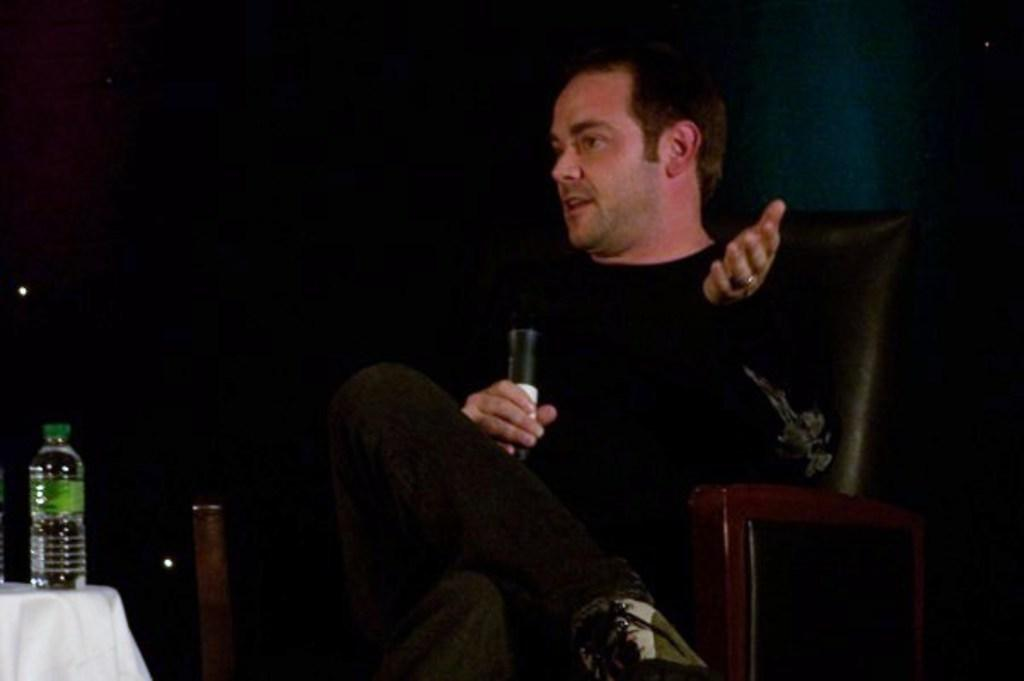Who is in the image? There is a man in the image. What is the man wearing? The man is wearing a black t-shirt. What is the man doing in the image? The man is sitting on a chair and holding a mic. What is in front of the man? There is a table in front of the man. What is on the table? There is a cloth and a bottle on the table. What type of spy equipment can be seen on the table in the image? There is no spy equipment present in the image; it features a man sitting on a chair, holding a mic, and a table with a cloth and a bottle on it. 